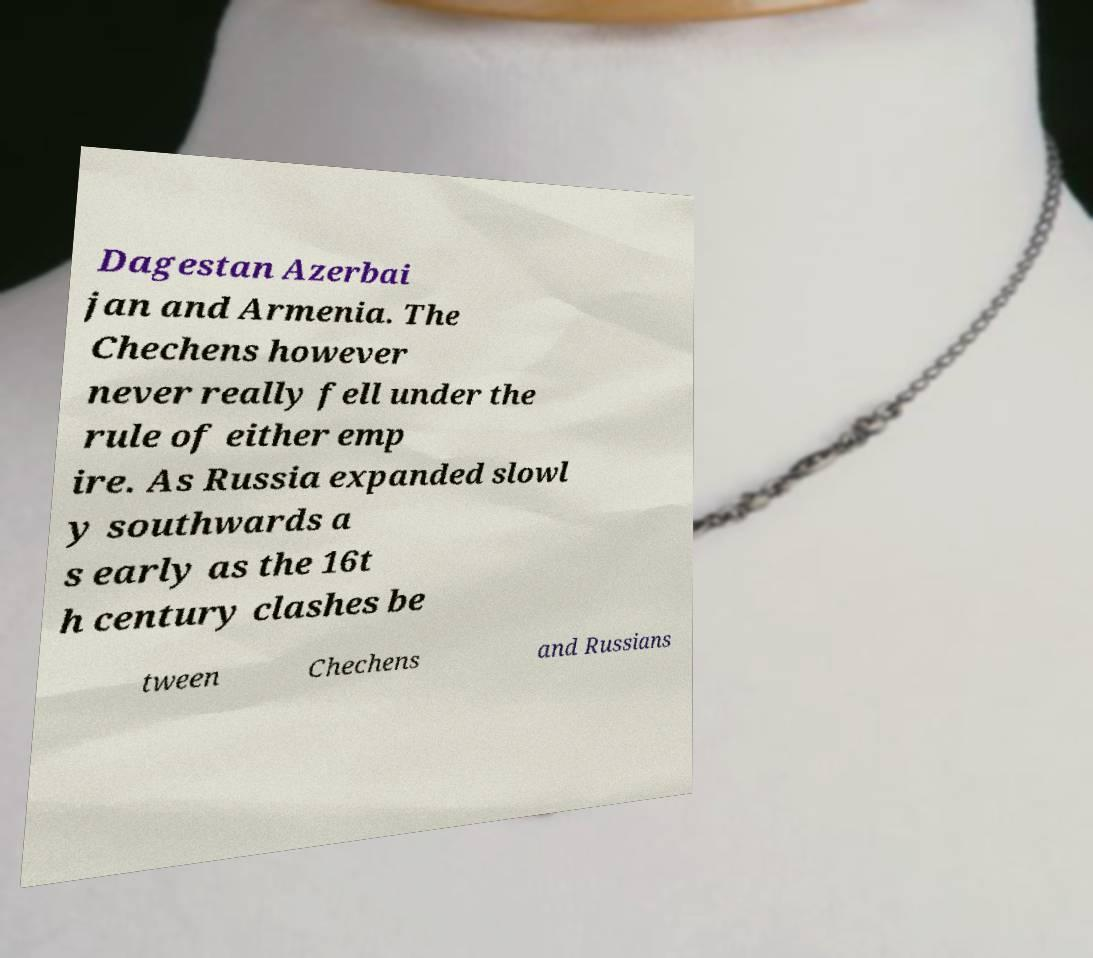I need the written content from this picture converted into text. Can you do that? Dagestan Azerbai jan and Armenia. The Chechens however never really fell under the rule of either emp ire. As Russia expanded slowl y southwards a s early as the 16t h century clashes be tween Chechens and Russians 